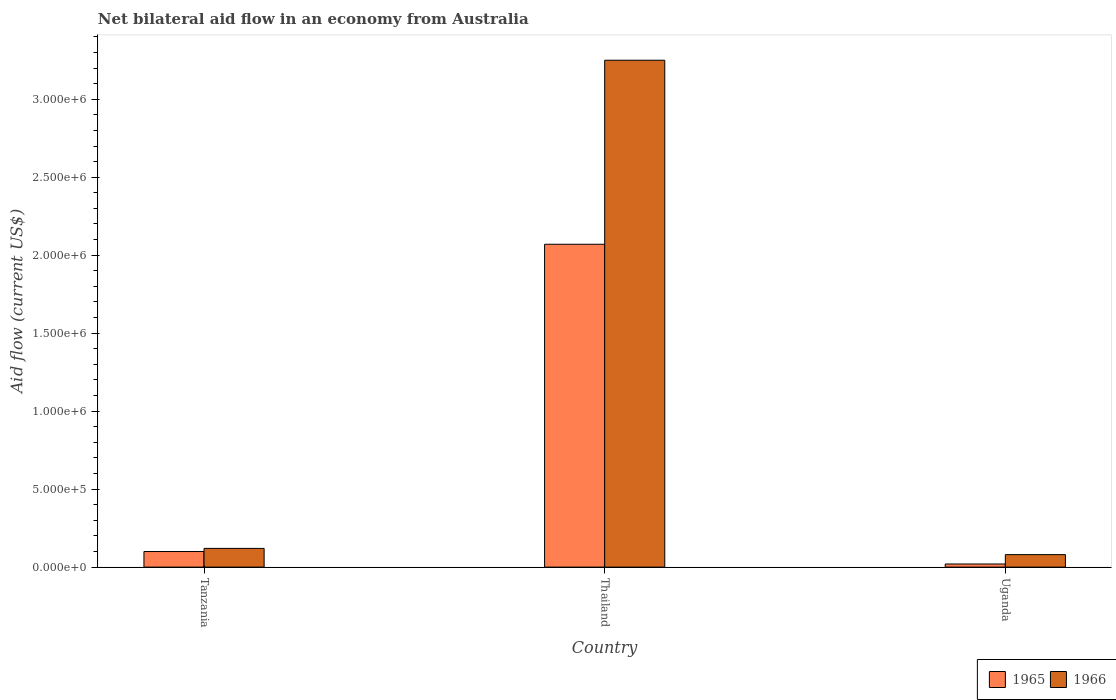How many different coloured bars are there?
Ensure brevity in your answer.  2. What is the label of the 1st group of bars from the left?
Provide a succinct answer. Tanzania. What is the net bilateral aid flow in 1966 in Thailand?
Your answer should be very brief. 3.25e+06. Across all countries, what is the maximum net bilateral aid flow in 1966?
Your answer should be compact. 3.25e+06. In which country was the net bilateral aid flow in 1966 maximum?
Keep it short and to the point. Thailand. In which country was the net bilateral aid flow in 1966 minimum?
Offer a very short reply. Uganda. What is the total net bilateral aid flow in 1966 in the graph?
Provide a short and direct response. 3.45e+06. What is the difference between the net bilateral aid flow in 1965 in Thailand and that in Uganda?
Offer a very short reply. 2.05e+06. What is the difference between the net bilateral aid flow in 1966 in Thailand and the net bilateral aid flow in 1965 in Tanzania?
Your response must be concise. 3.15e+06. What is the average net bilateral aid flow in 1965 per country?
Provide a succinct answer. 7.30e+05. What is the difference between the net bilateral aid flow of/in 1966 and net bilateral aid flow of/in 1965 in Thailand?
Provide a succinct answer. 1.18e+06. In how many countries, is the net bilateral aid flow in 1965 greater than 200000 US$?
Offer a terse response. 1. What is the ratio of the net bilateral aid flow in 1965 in Thailand to that in Uganda?
Give a very brief answer. 103.5. Is the difference between the net bilateral aid flow in 1966 in Tanzania and Uganda greater than the difference between the net bilateral aid flow in 1965 in Tanzania and Uganda?
Ensure brevity in your answer.  No. What is the difference between the highest and the second highest net bilateral aid flow in 1966?
Make the answer very short. 3.17e+06. What is the difference between the highest and the lowest net bilateral aid flow in 1965?
Offer a terse response. 2.05e+06. In how many countries, is the net bilateral aid flow in 1966 greater than the average net bilateral aid flow in 1966 taken over all countries?
Offer a terse response. 1. What does the 1st bar from the left in Thailand represents?
Your response must be concise. 1965. What does the 1st bar from the right in Uganda represents?
Your response must be concise. 1966. How many countries are there in the graph?
Provide a short and direct response. 3. Are the values on the major ticks of Y-axis written in scientific E-notation?
Offer a terse response. Yes. Does the graph contain any zero values?
Give a very brief answer. No. How are the legend labels stacked?
Provide a succinct answer. Horizontal. What is the title of the graph?
Ensure brevity in your answer.  Net bilateral aid flow in an economy from Australia. What is the label or title of the X-axis?
Make the answer very short. Country. What is the label or title of the Y-axis?
Provide a short and direct response. Aid flow (current US$). What is the Aid flow (current US$) in 1965 in Tanzania?
Offer a very short reply. 1.00e+05. What is the Aid flow (current US$) of 1966 in Tanzania?
Your response must be concise. 1.20e+05. What is the Aid flow (current US$) in 1965 in Thailand?
Provide a short and direct response. 2.07e+06. What is the Aid flow (current US$) in 1966 in Thailand?
Your response must be concise. 3.25e+06. Across all countries, what is the maximum Aid flow (current US$) in 1965?
Offer a terse response. 2.07e+06. Across all countries, what is the maximum Aid flow (current US$) in 1966?
Your answer should be compact. 3.25e+06. Across all countries, what is the minimum Aid flow (current US$) of 1965?
Provide a short and direct response. 2.00e+04. What is the total Aid flow (current US$) of 1965 in the graph?
Your answer should be compact. 2.19e+06. What is the total Aid flow (current US$) in 1966 in the graph?
Offer a very short reply. 3.45e+06. What is the difference between the Aid flow (current US$) of 1965 in Tanzania and that in Thailand?
Your response must be concise. -1.97e+06. What is the difference between the Aid flow (current US$) of 1966 in Tanzania and that in Thailand?
Make the answer very short. -3.13e+06. What is the difference between the Aid flow (current US$) of 1965 in Thailand and that in Uganda?
Make the answer very short. 2.05e+06. What is the difference between the Aid flow (current US$) of 1966 in Thailand and that in Uganda?
Offer a terse response. 3.17e+06. What is the difference between the Aid flow (current US$) of 1965 in Tanzania and the Aid flow (current US$) of 1966 in Thailand?
Provide a succinct answer. -3.15e+06. What is the difference between the Aid flow (current US$) of 1965 in Thailand and the Aid flow (current US$) of 1966 in Uganda?
Give a very brief answer. 1.99e+06. What is the average Aid flow (current US$) in 1965 per country?
Your answer should be very brief. 7.30e+05. What is the average Aid flow (current US$) of 1966 per country?
Your answer should be very brief. 1.15e+06. What is the difference between the Aid flow (current US$) in 1965 and Aid flow (current US$) in 1966 in Thailand?
Provide a succinct answer. -1.18e+06. What is the difference between the Aid flow (current US$) of 1965 and Aid flow (current US$) of 1966 in Uganda?
Keep it short and to the point. -6.00e+04. What is the ratio of the Aid flow (current US$) in 1965 in Tanzania to that in Thailand?
Your answer should be very brief. 0.05. What is the ratio of the Aid flow (current US$) of 1966 in Tanzania to that in Thailand?
Your answer should be compact. 0.04. What is the ratio of the Aid flow (current US$) in 1965 in Tanzania to that in Uganda?
Give a very brief answer. 5. What is the ratio of the Aid flow (current US$) in 1965 in Thailand to that in Uganda?
Keep it short and to the point. 103.5. What is the ratio of the Aid flow (current US$) of 1966 in Thailand to that in Uganda?
Your answer should be very brief. 40.62. What is the difference between the highest and the second highest Aid flow (current US$) in 1965?
Your answer should be very brief. 1.97e+06. What is the difference between the highest and the second highest Aid flow (current US$) of 1966?
Offer a very short reply. 3.13e+06. What is the difference between the highest and the lowest Aid flow (current US$) of 1965?
Offer a very short reply. 2.05e+06. What is the difference between the highest and the lowest Aid flow (current US$) of 1966?
Give a very brief answer. 3.17e+06. 